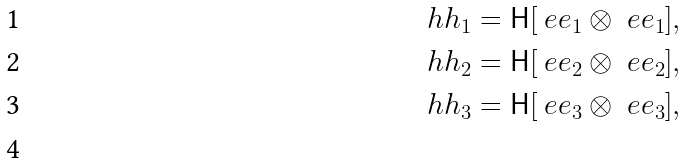<formula> <loc_0><loc_0><loc_500><loc_500>\ h h _ { 1 } = \mathsf H [ \ e e _ { 1 } \otimes \ e e _ { 1 } ] , \\ \ h h _ { 2 } = \mathsf H [ \ e e _ { 2 } \otimes \ e e _ { 2 } ] , \\ \ h h _ { 3 } = \mathsf H [ \ e e _ { 3 } \otimes \ e e _ { 3 } ] , \\</formula> 